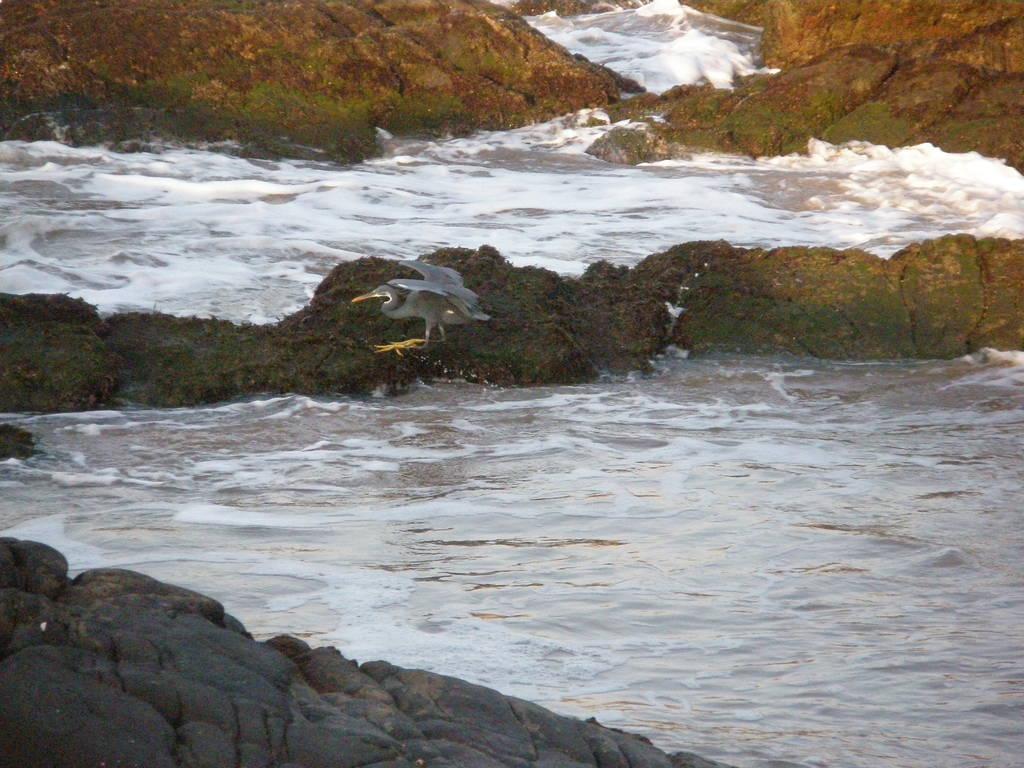Please provide a concise description of this image. In the picture we can see a rock surface and behind it we can see water and behind it we can again see water with white color tides. 